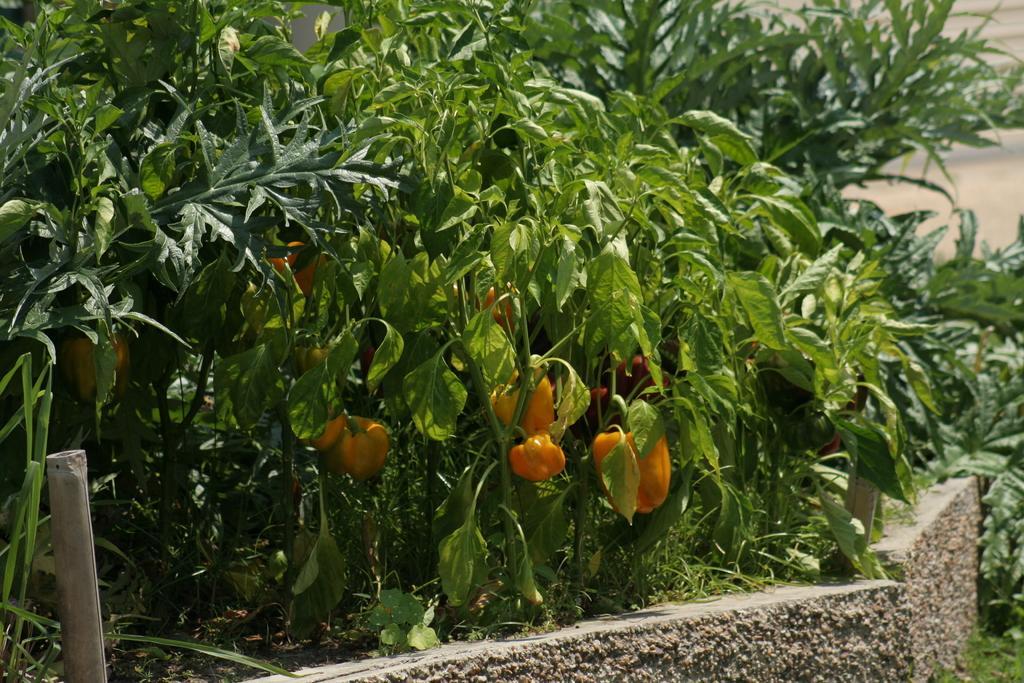Describe this image in one or two sentences. In this picture I can see the capsicums and plants in the middle, on the left side it looks like an iron rod, at the bottom there are stones. 